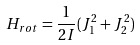<formula> <loc_0><loc_0><loc_500><loc_500>H _ { r o t } = \frac { 1 } { 2 I } ( J _ { 1 } ^ { 2 } + J _ { 2 } ^ { 2 } )</formula> 